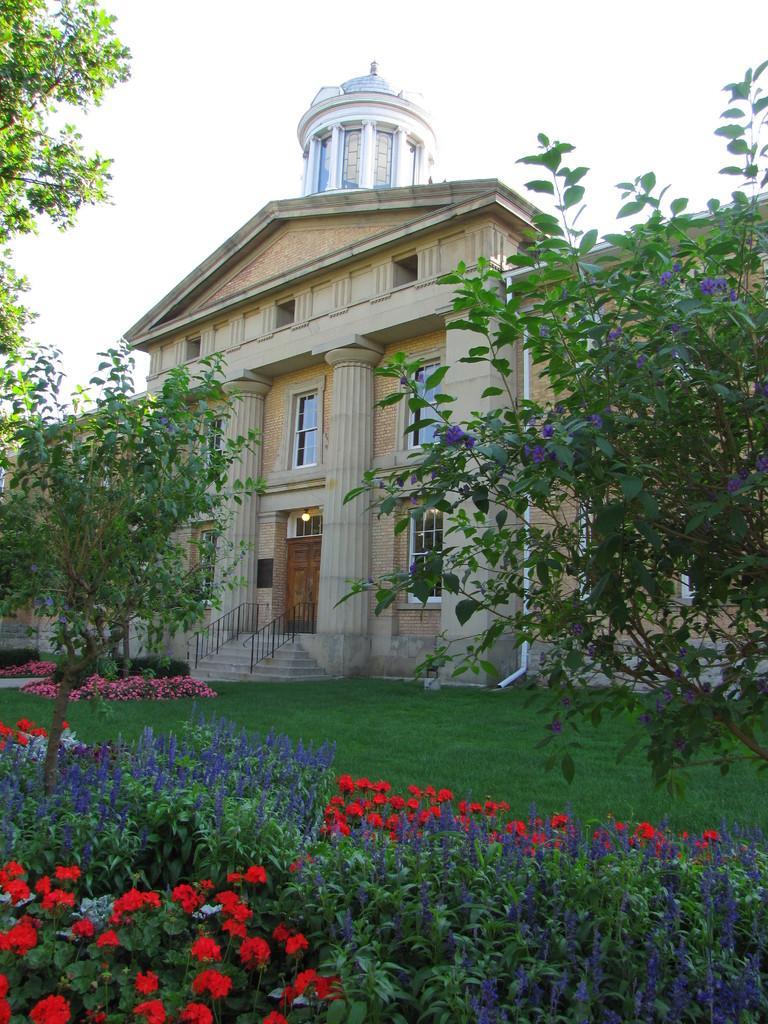Describe this image in one or two sentences. We can see flowers,plants,grass and trees and we can see building,pillars,windows and sky. 